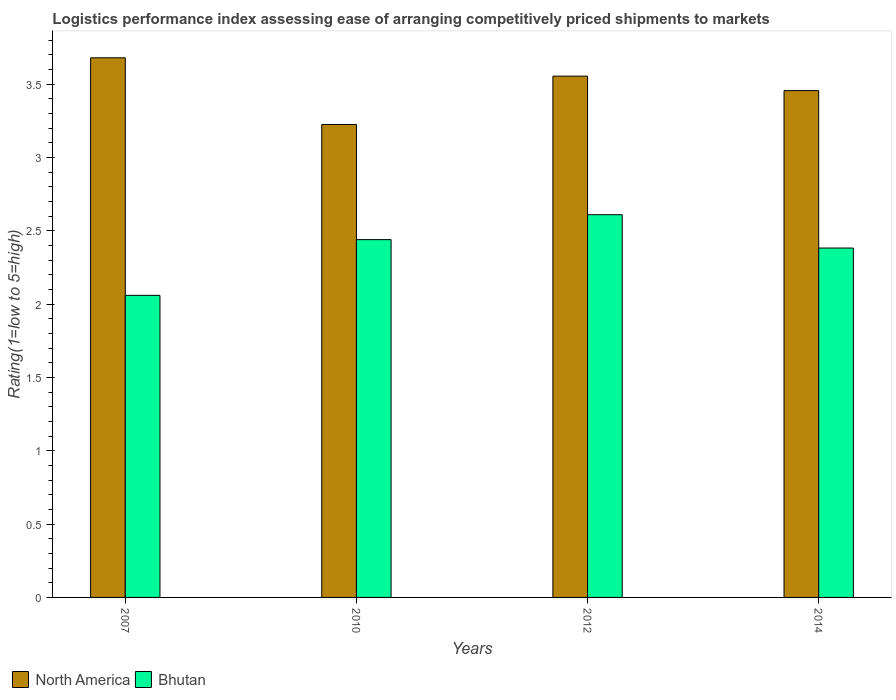Are the number of bars on each tick of the X-axis equal?
Your response must be concise. Yes. How many bars are there on the 3rd tick from the right?
Ensure brevity in your answer.  2. What is the label of the 1st group of bars from the left?
Give a very brief answer. 2007. What is the Logistic performance index in North America in 2014?
Provide a short and direct response. 3.46. Across all years, what is the maximum Logistic performance index in Bhutan?
Provide a succinct answer. 2.61. Across all years, what is the minimum Logistic performance index in North America?
Offer a terse response. 3.23. In which year was the Logistic performance index in Bhutan maximum?
Give a very brief answer. 2012. What is the total Logistic performance index in Bhutan in the graph?
Offer a terse response. 9.49. What is the difference between the Logistic performance index in Bhutan in 2007 and that in 2010?
Give a very brief answer. -0.38. What is the difference between the Logistic performance index in North America in 2010 and the Logistic performance index in Bhutan in 2014?
Make the answer very short. 0.84. What is the average Logistic performance index in North America per year?
Your answer should be compact. 3.48. In the year 2010, what is the difference between the Logistic performance index in North America and Logistic performance index in Bhutan?
Give a very brief answer. 0.79. In how many years, is the Logistic performance index in Bhutan greater than 1.2?
Provide a succinct answer. 4. What is the ratio of the Logistic performance index in North America in 2007 to that in 2014?
Ensure brevity in your answer.  1.06. Is the Logistic performance index in Bhutan in 2010 less than that in 2014?
Provide a short and direct response. No. Is the difference between the Logistic performance index in North America in 2012 and 2014 greater than the difference between the Logistic performance index in Bhutan in 2012 and 2014?
Provide a short and direct response. No. What is the difference between the highest and the second highest Logistic performance index in Bhutan?
Provide a short and direct response. 0.17. What is the difference between the highest and the lowest Logistic performance index in North America?
Make the answer very short. 0.46. In how many years, is the Logistic performance index in Bhutan greater than the average Logistic performance index in Bhutan taken over all years?
Your answer should be compact. 3. Is the sum of the Logistic performance index in North America in 2007 and 2012 greater than the maximum Logistic performance index in Bhutan across all years?
Offer a terse response. Yes. What does the 2nd bar from the left in 2012 represents?
Your answer should be very brief. Bhutan. How many bars are there?
Offer a terse response. 8. How many years are there in the graph?
Offer a very short reply. 4. What is the difference between two consecutive major ticks on the Y-axis?
Provide a succinct answer. 0.5. Does the graph contain any zero values?
Your answer should be very brief. No. How many legend labels are there?
Make the answer very short. 2. How are the legend labels stacked?
Your response must be concise. Horizontal. What is the title of the graph?
Offer a terse response. Logistics performance index assessing ease of arranging competitively priced shipments to markets. What is the label or title of the X-axis?
Your response must be concise. Years. What is the label or title of the Y-axis?
Give a very brief answer. Rating(1=low to 5=high). What is the Rating(1=low to 5=high) in North America in 2007?
Give a very brief answer. 3.68. What is the Rating(1=low to 5=high) of Bhutan in 2007?
Ensure brevity in your answer.  2.06. What is the Rating(1=low to 5=high) of North America in 2010?
Offer a very short reply. 3.23. What is the Rating(1=low to 5=high) in Bhutan in 2010?
Your answer should be compact. 2.44. What is the Rating(1=low to 5=high) of North America in 2012?
Provide a short and direct response. 3.56. What is the Rating(1=low to 5=high) of Bhutan in 2012?
Ensure brevity in your answer.  2.61. What is the Rating(1=low to 5=high) in North America in 2014?
Offer a very short reply. 3.46. What is the Rating(1=low to 5=high) of Bhutan in 2014?
Provide a short and direct response. 2.38. Across all years, what is the maximum Rating(1=low to 5=high) of North America?
Your answer should be very brief. 3.68. Across all years, what is the maximum Rating(1=low to 5=high) of Bhutan?
Make the answer very short. 2.61. Across all years, what is the minimum Rating(1=low to 5=high) in North America?
Offer a very short reply. 3.23. Across all years, what is the minimum Rating(1=low to 5=high) of Bhutan?
Your answer should be very brief. 2.06. What is the total Rating(1=low to 5=high) in North America in the graph?
Provide a short and direct response. 13.92. What is the total Rating(1=low to 5=high) in Bhutan in the graph?
Offer a terse response. 9.49. What is the difference between the Rating(1=low to 5=high) in North America in 2007 and that in 2010?
Make the answer very short. 0.46. What is the difference between the Rating(1=low to 5=high) in Bhutan in 2007 and that in 2010?
Give a very brief answer. -0.38. What is the difference between the Rating(1=low to 5=high) of Bhutan in 2007 and that in 2012?
Your answer should be very brief. -0.55. What is the difference between the Rating(1=low to 5=high) in North America in 2007 and that in 2014?
Provide a short and direct response. 0.22. What is the difference between the Rating(1=low to 5=high) in Bhutan in 2007 and that in 2014?
Keep it short and to the point. -0.32. What is the difference between the Rating(1=low to 5=high) in North America in 2010 and that in 2012?
Keep it short and to the point. -0.33. What is the difference between the Rating(1=low to 5=high) in Bhutan in 2010 and that in 2012?
Your answer should be very brief. -0.17. What is the difference between the Rating(1=low to 5=high) of North America in 2010 and that in 2014?
Your response must be concise. -0.23. What is the difference between the Rating(1=low to 5=high) of Bhutan in 2010 and that in 2014?
Your response must be concise. 0.06. What is the difference between the Rating(1=low to 5=high) in North America in 2012 and that in 2014?
Your answer should be compact. 0.1. What is the difference between the Rating(1=low to 5=high) in Bhutan in 2012 and that in 2014?
Provide a succinct answer. 0.23. What is the difference between the Rating(1=low to 5=high) in North America in 2007 and the Rating(1=low to 5=high) in Bhutan in 2010?
Your answer should be very brief. 1.24. What is the difference between the Rating(1=low to 5=high) in North America in 2007 and the Rating(1=low to 5=high) in Bhutan in 2012?
Provide a short and direct response. 1.07. What is the difference between the Rating(1=low to 5=high) of North America in 2007 and the Rating(1=low to 5=high) of Bhutan in 2014?
Offer a very short reply. 1.3. What is the difference between the Rating(1=low to 5=high) of North America in 2010 and the Rating(1=low to 5=high) of Bhutan in 2012?
Offer a terse response. 0.61. What is the difference between the Rating(1=low to 5=high) of North America in 2010 and the Rating(1=low to 5=high) of Bhutan in 2014?
Give a very brief answer. 0.84. What is the difference between the Rating(1=low to 5=high) of North America in 2012 and the Rating(1=low to 5=high) of Bhutan in 2014?
Your answer should be very brief. 1.17. What is the average Rating(1=low to 5=high) of North America per year?
Your response must be concise. 3.48. What is the average Rating(1=low to 5=high) of Bhutan per year?
Offer a very short reply. 2.37. In the year 2007, what is the difference between the Rating(1=low to 5=high) in North America and Rating(1=low to 5=high) in Bhutan?
Give a very brief answer. 1.62. In the year 2010, what is the difference between the Rating(1=low to 5=high) in North America and Rating(1=low to 5=high) in Bhutan?
Give a very brief answer. 0.79. In the year 2012, what is the difference between the Rating(1=low to 5=high) in North America and Rating(1=low to 5=high) in Bhutan?
Make the answer very short. 0.94. In the year 2014, what is the difference between the Rating(1=low to 5=high) of North America and Rating(1=low to 5=high) of Bhutan?
Your answer should be very brief. 1.07. What is the ratio of the Rating(1=low to 5=high) in North America in 2007 to that in 2010?
Make the answer very short. 1.14. What is the ratio of the Rating(1=low to 5=high) in Bhutan in 2007 to that in 2010?
Offer a very short reply. 0.84. What is the ratio of the Rating(1=low to 5=high) of North America in 2007 to that in 2012?
Provide a succinct answer. 1.04. What is the ratio of the Rating(1=low to 5=high) of Bhutan in 2007 to that in 2012?
Provide a short and direct response. 0.79. What is the ratio of the Rating(1=low to 5=high) in North America in 2007 to that in 2014?
Offer a terse response. 1.06. What is the ratio of the Rating(1=low to 5=high) of Bhutan in 2007 to that in 2014?
Your answer should be compact. 0.86. What is the ratio of the Rating(1=low to 5=high) of North America in 2010 to that in 2012?
Provide a succinct answer. 0.91. What is the ratio of the Rating(1=low to 5=high) of Bhutan in 2010 to that in 2012?
Ensure brevity in your answer.  0.93. What is the ratio of the Rating(1=low to 5=high) of North America in 2010 to that in 2014?
Keep it short and to the point. 0.93. What is the ratio of the Rating(1=low to 5=high) of Bhutan in 2010 to that in 2014?
Offer a very short reply. 1.02. What is the ratio of the Rating(1=low to 5=high) in North America in 2012 to that in 2014?
Provide a short and direct response. 1.03. What is the ratio of the Rating(1=low to 5=high) in Bhutan in 2012 to that in 2014?
Provide a short and direct response. 1.1. What is the difference between the highest and the second highest Rating(1=low to 5=high) of Bhutan?
Offer a very short reply. 0.17. What is the difference between the highest and the lowest Rating(1=low to 5=high) of North America?
Ensure brevity in your answer.  0.46. What is the difference between the highest and the lowest Rating(1=low to 5=high) in Bhutan?
Make the answer very short. 0.55. 